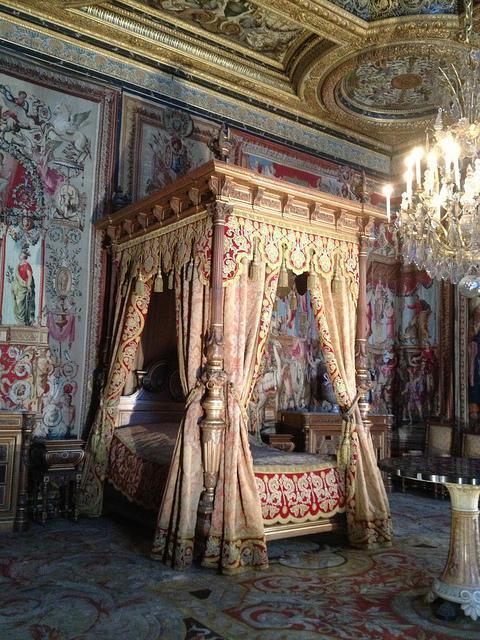What is needed to light the candles on the chandeliers?
Indicate the correct response and explain using: 'Answer: answer
Rationale: rationale.'
Options: Air, minerals, fire, water. Answer: fire.
Rationale: It is a candle chandelier. 